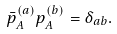Convert formula to latex. <formula><loc_0><loc_0><loc_500><loc_500>\bar { p } _ { A } ^ { ( a ) } p _ { A } ^ { ( b ) } = \delta _ { a b } .</formula> 